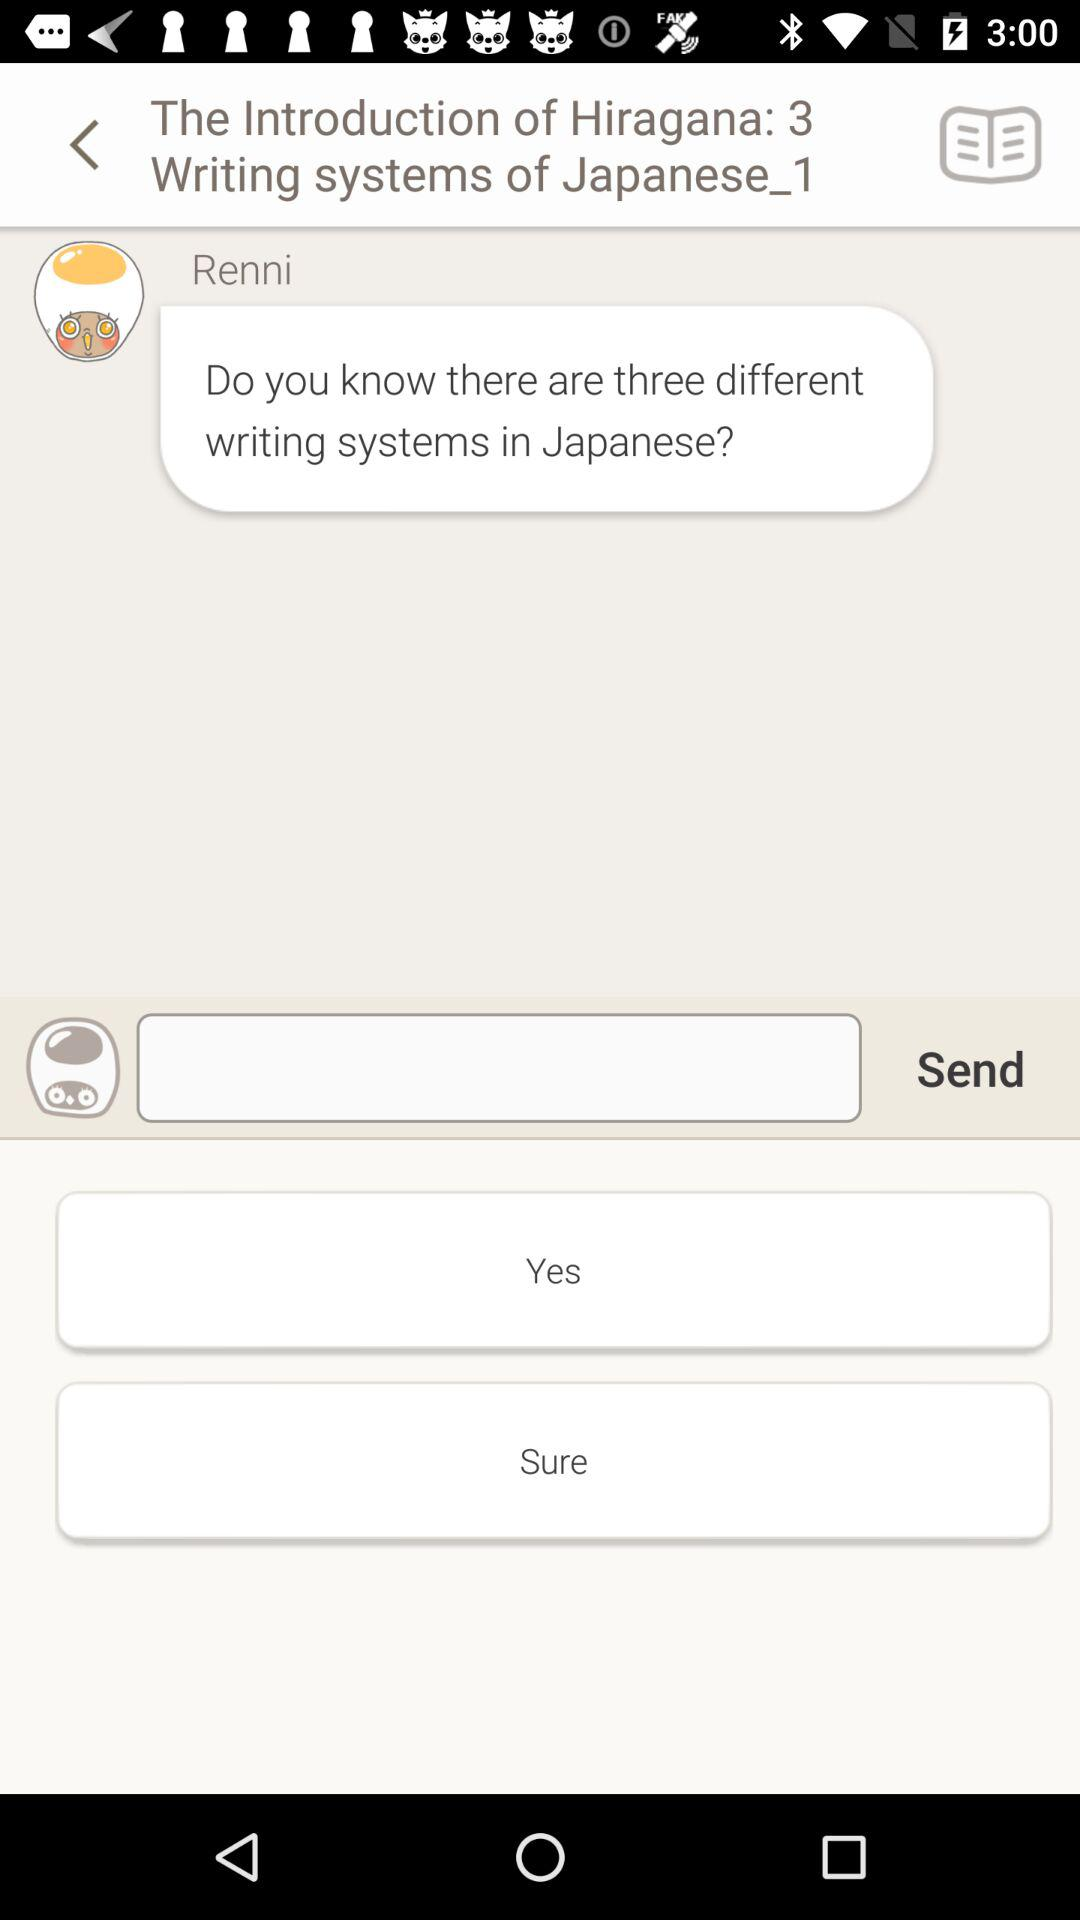How many different types of writing systems are there in Japanese? There are three different types of writing styles in Japanese. 